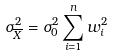<formula> <loc_0><loc_0><loc_500><loc_500>\sigma _ { \overline { X } } ^ { 2 } = \sigma _ { 0 } ^ { 2 } \sum _ { i = 1 } ^ { n } w _ { i } ^ { 2 }</formula> 